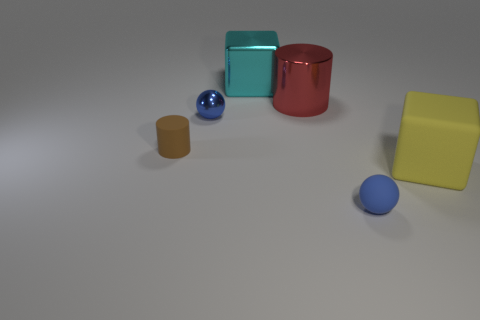Are there any other things that are the same color as the small rubber ball?
Provide a short and direct response. Yes. There is a tiny sphere in front of the brown thing; is its color the same as the metal object that is in front of the red metallic cylinder?
Give a very brief answer. Yes. The large block that is on the left side of the big yellow matte cube is what color?
Your answer should be compact. Cyan. What number of rubber things are cylinders or large brown spheres?
Your response must be concise. 1. Are there any yellow rubber things that are right of the rubber object that is in front of the large object in front of the brown thing?
Offer a very short reply. Yes. There is a cyan block; how many metallic balls are to the left of it?
Your answer should be compact. 1. What material is the thing that is the same color as the tiny shiny ball?
Give a very brief answer. Rubber. What number of tiny things are either brown rubber cylinders or blocks?
Offer a very short reply. 1. There is a big metal object that is to the left of the large red cylinder; what is its shape?
Offer a terse response. Cube. Is there another sphere of the same color as the metal sphere?
Offer a terse response. Yes. 